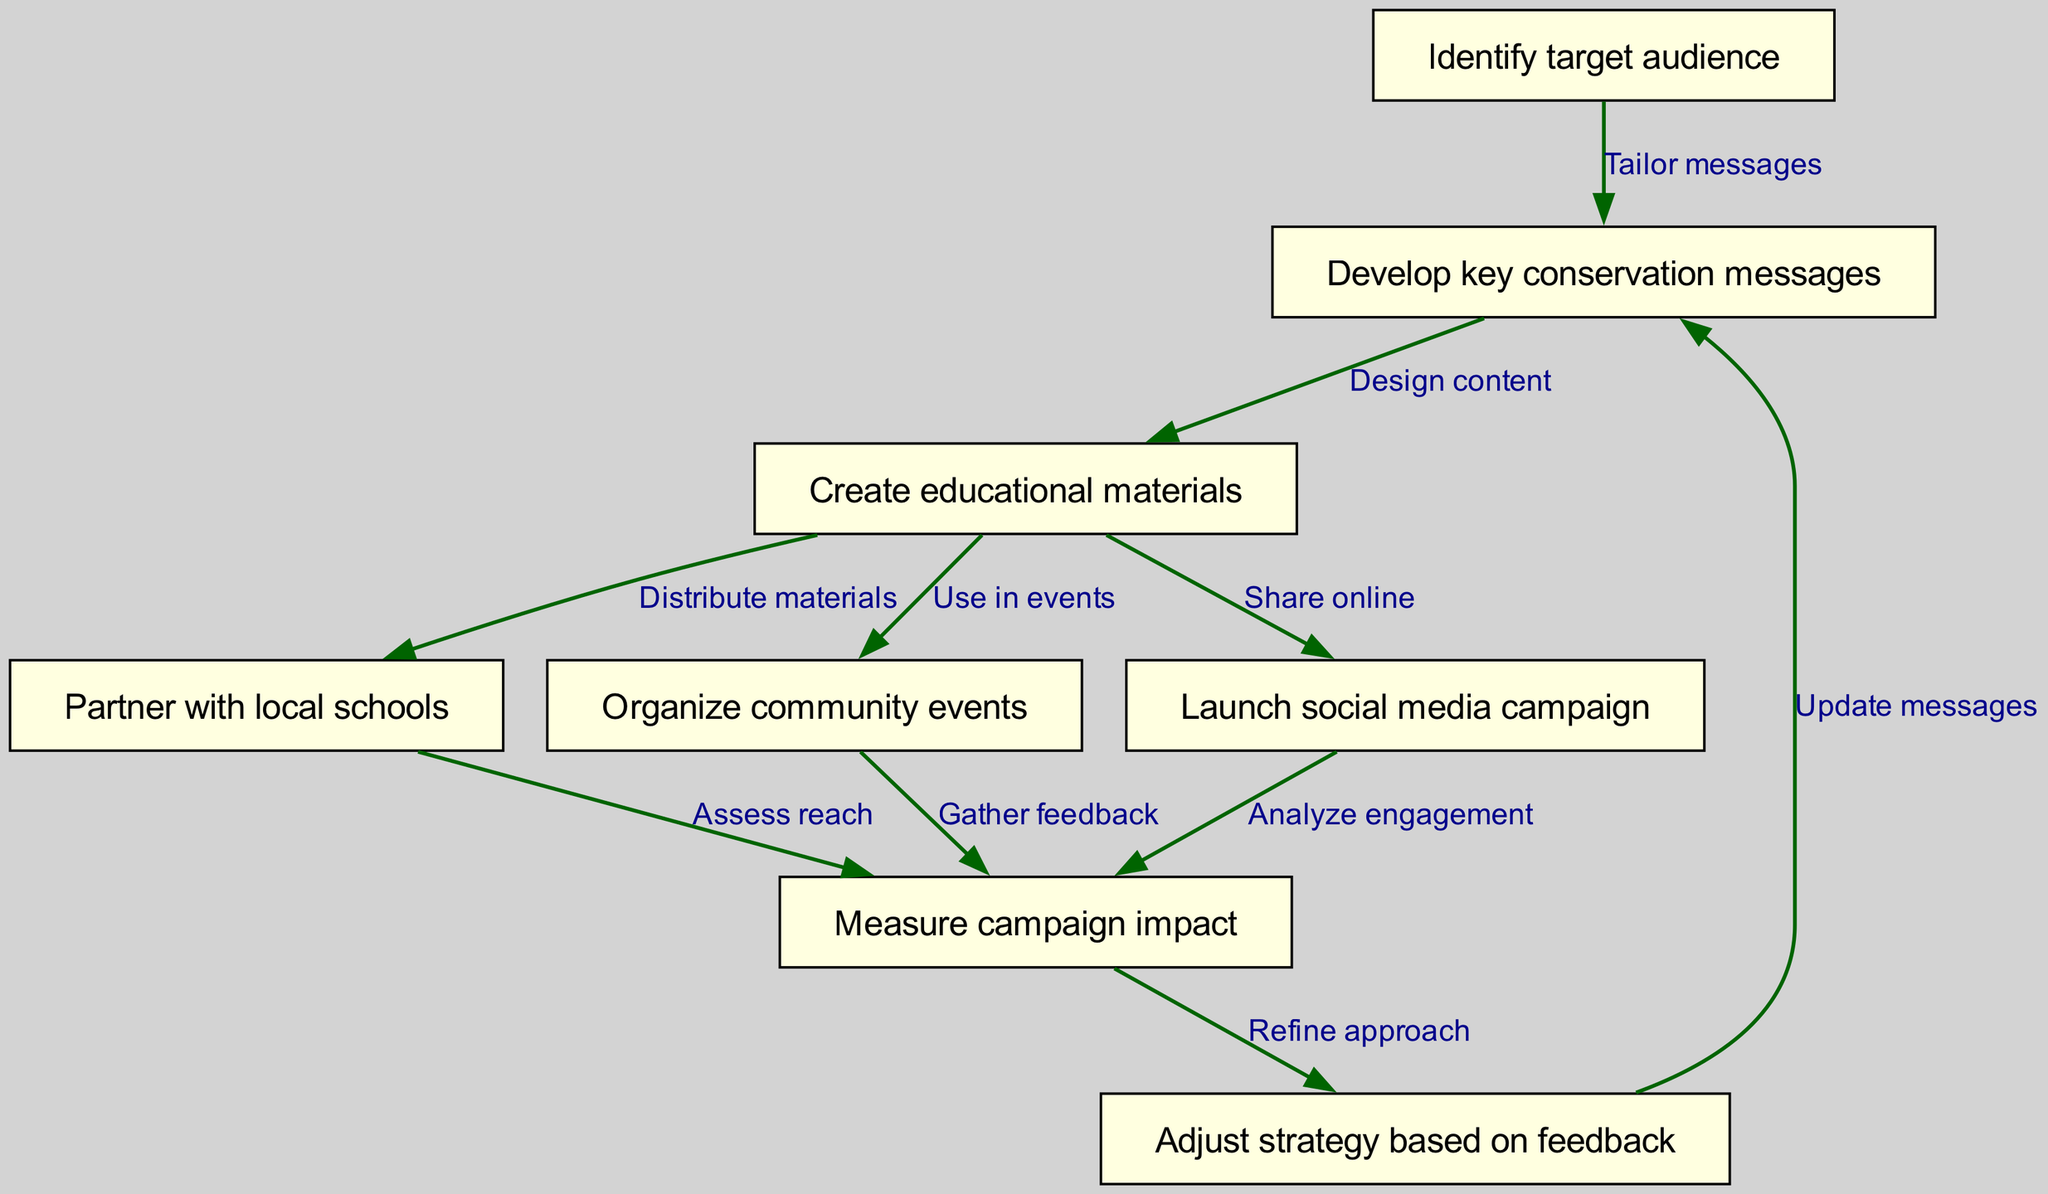What is the first step in the campaign flow? The first step in the flow is represented by the first node, which is "Identify target audience." This indicates that understanding who the campaign is aimed at is the starting point of the process.
Answer: Identify target audience How many total nodes are present in the diagram? By counting all the nodes listed, we find there are eight steps outlined in the campaign flow. These include various actions from identifying the audience to adjusting strategies.
Answer: 8 What is the last step of the campaign flow? The last step is indicated by the final node, which is "Adjust strategy based on feedback." This suggests that after measuring the impact, the approach is refined to improve future efforts.
Answer: Adjust strategy based on feedback Which node involves partnering with local institutions? The node "Partner with local schools" represents the involvement with educational institutions. It is a key step where collaboration occurs to increase outreach and education efforts through schools.
Answer: Partner with local schools What unique action does the edge from "Measure campaign impact" to "Adjust strategy based on feedback" signify? This edge represents a feedback loop where the impact measured from various actions in the campaign informs necessary adjustments in strategy. It emphasizes the iterative nature of the campaign based on outcomes.
Answer: Refine approach Which two nodes directly relate to community engagement? The nodes "Organize community events" and "Partner with local schools" both focus on engaging the community. These actions aim to raise awareness and involvement from the local population in conservation efforts.
Answer: Organize community events, Partner with local schools What is the relationship between "Create educational materials" and "Launch social media campaign"? "Create educational materials" feeds into "Launch social media campaign" as these materials are to be shared online, indicating a direct flow of information and resources from education to outreach.
Answer: Share online How does the campaign evaluate its effectiveness? The campaign evaluates its effectiveness through steps like "Measure campaign impact," which involves assessing the reach of the campaign and gathering feedback from various activities to inform future strategies.
Answer: Measure campaign impact 